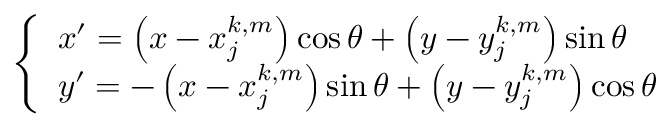<formula> <loc_0><loc_0><loc_500><loc_500>\left \{ \begin{array} { l } { { x ^ { \prime } = \left ( x - x _ { j } ^ { k , m } \right ) \cos \theta + \left ( y - y _ { j } ^ { k , m } \right ) \sin \theta } } \\ { { y ^ { \prime } = - \left ( x - x _ { j } ^ { k , m } \right ) \sin \theta + \left ( y - y _ { j } ^ { k , m } \right ) \cos \theta } } \end{array}</formula> 